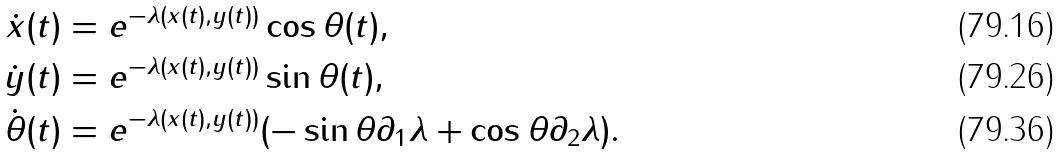<formula> <loc_0><loc_0><loc_500><loc_500>\dot { x } ( t ) & = e ^ { - \lambda ( x ( t ) , y ( t ) ) } \cos \theta ( t ) , \\ \dot { y } ( t ) & = e ^ { - \lambda ( x ( t ) , y ( t ) ) } \sin \theta ( t ) , \\ \dot { \theta } ( t ) & = e ^ { - \lambda ( x ( t ) , y ( t ) ) } ( - \sin \theta \partial _ { 1 } \lambda + \cos \theta \partial _ { 2 } \lambda ) .</formula> 